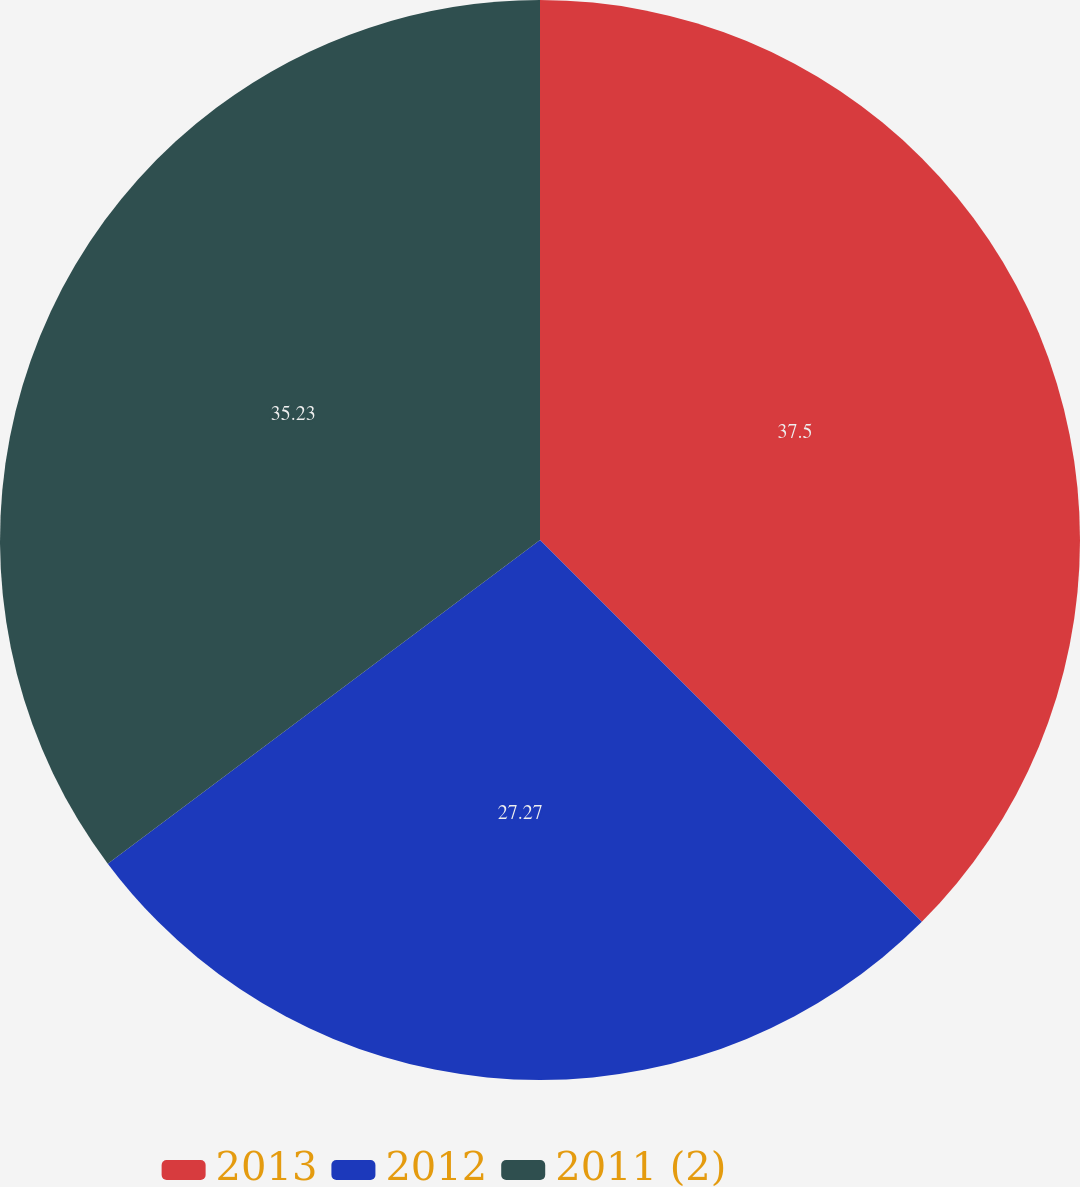Convert chart to OTSL. <chart><loc_0><loc_0><loc_500><loc_500><pie_chart><fcel>2013<fcel>2012<fcel>2011 (2)<nl><fcel>37.5%<fcel>27.27%<fcel>35.23%<nl></chart> 